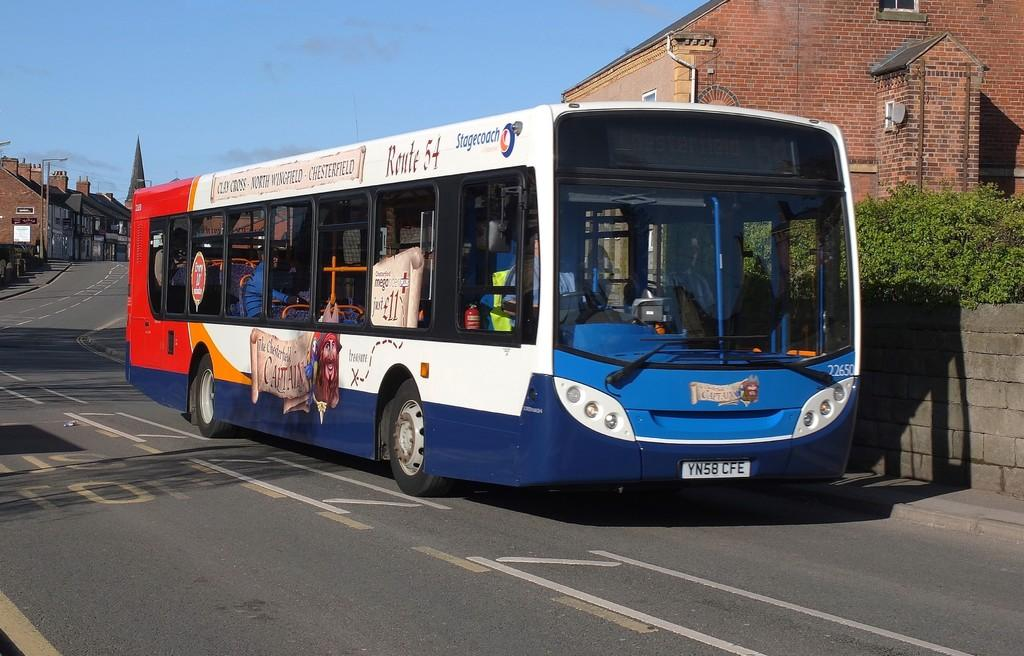<image>
Describe the image concisely. The registration of the blue and white bu is YN58 CFE. 